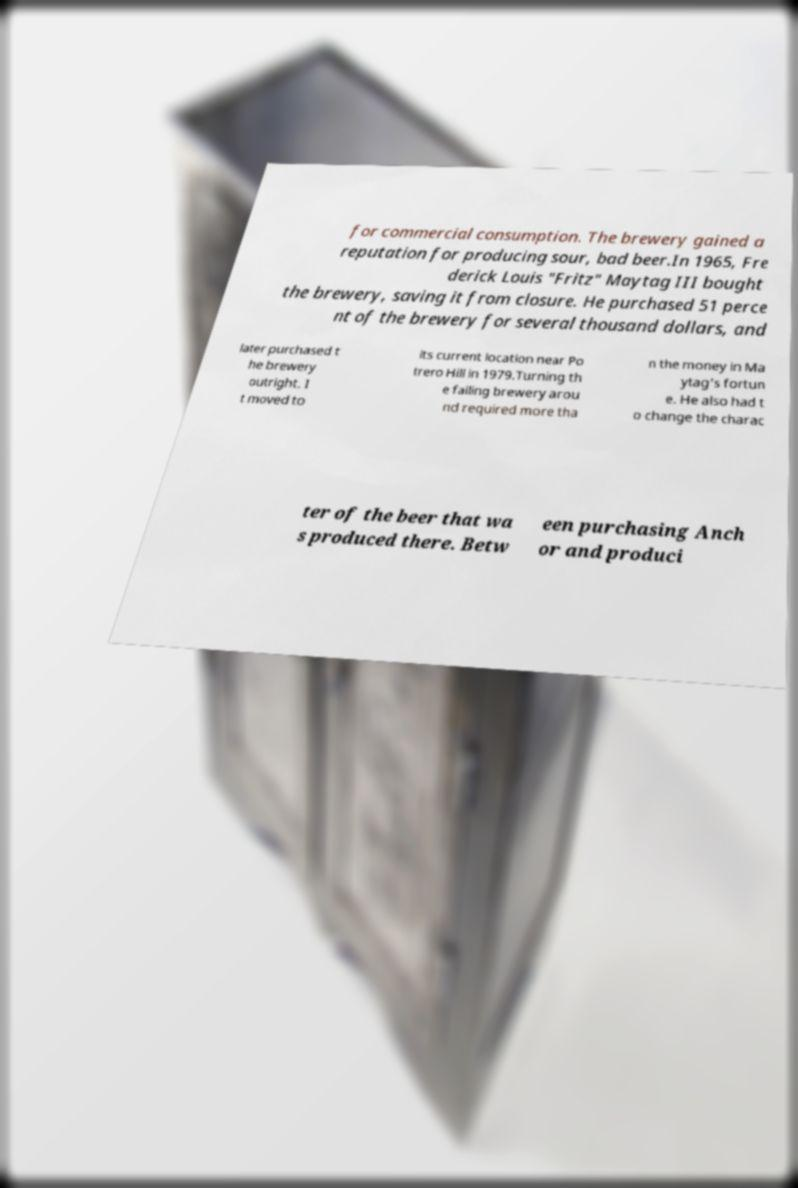Could you extract and type out the text from this image? for commercial consumption. The brewery gained a reputation for producing sour, bad beer.In 1965, Fre derick Louis "Fritz" Maytag III bought the brewery, saving it from closure. He purchased 51 perce nt of the brewery for several thousand dollars, and later purchased t he brewery outright. I t moved to its current location near Po trero Hill in 1979.Turning th e failing brewery arou nd required more tha n the money in Ma ytag's fortun e. He also had t o change the charac ter of the beer that wa s produced there. Betw een purchasing Anch or and produci 